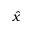<formula> <loc_0><loc_0><loc_500><loc_500>\hat { x }</formula> 